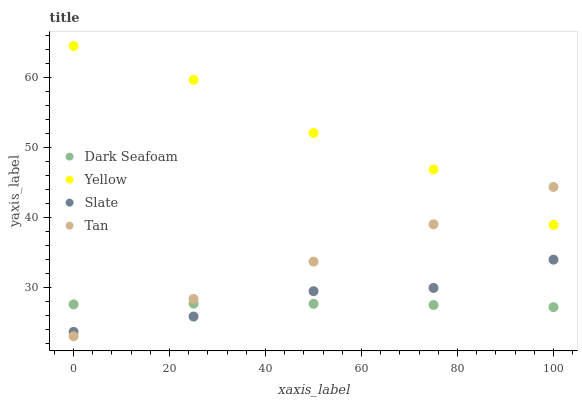Does Dark Seafoam have the minimum area under the curve?
Answer yes or no. Yes. Does Yellow have the maximum area under the curve?
Answer yes or no. Yes. Does Tan have the minimum area under the curve?
Answer yes or no. No. Does Tan have the maximum area under the curve?
Answer yes or no. No. Is Tan the smoothest?
Answer yes or no. Yes. Is Slate the roughest?
Answer yes or no. Yes. Is Slate the smoothest?
Answer yes or no. No. Is Tan the roughest?
Answer yes or no. No. Does Tan have the lowest value?
Answer yes or no. Yes. Does Slate have the lowest value?
Answer yes or no. No. Does Yellow have the highest value?
Answer yes or no. Yes. Does Tan have the highest value?
Answer yes or no. No. Is Slate less than Yellow?
Answer yes or no. Yes. Is Yellow greater than Dark Seafoam?
Answer yes or no. Yes. Does Tan intersect Slate?
Answer yes or no. Yes. Is Tan less than Slate?
Answer yes or no. No. Is Tan greater than Slate?
Answer yes or no. No. Does Slate intersect Yellow?
Answer yes or no. No. 